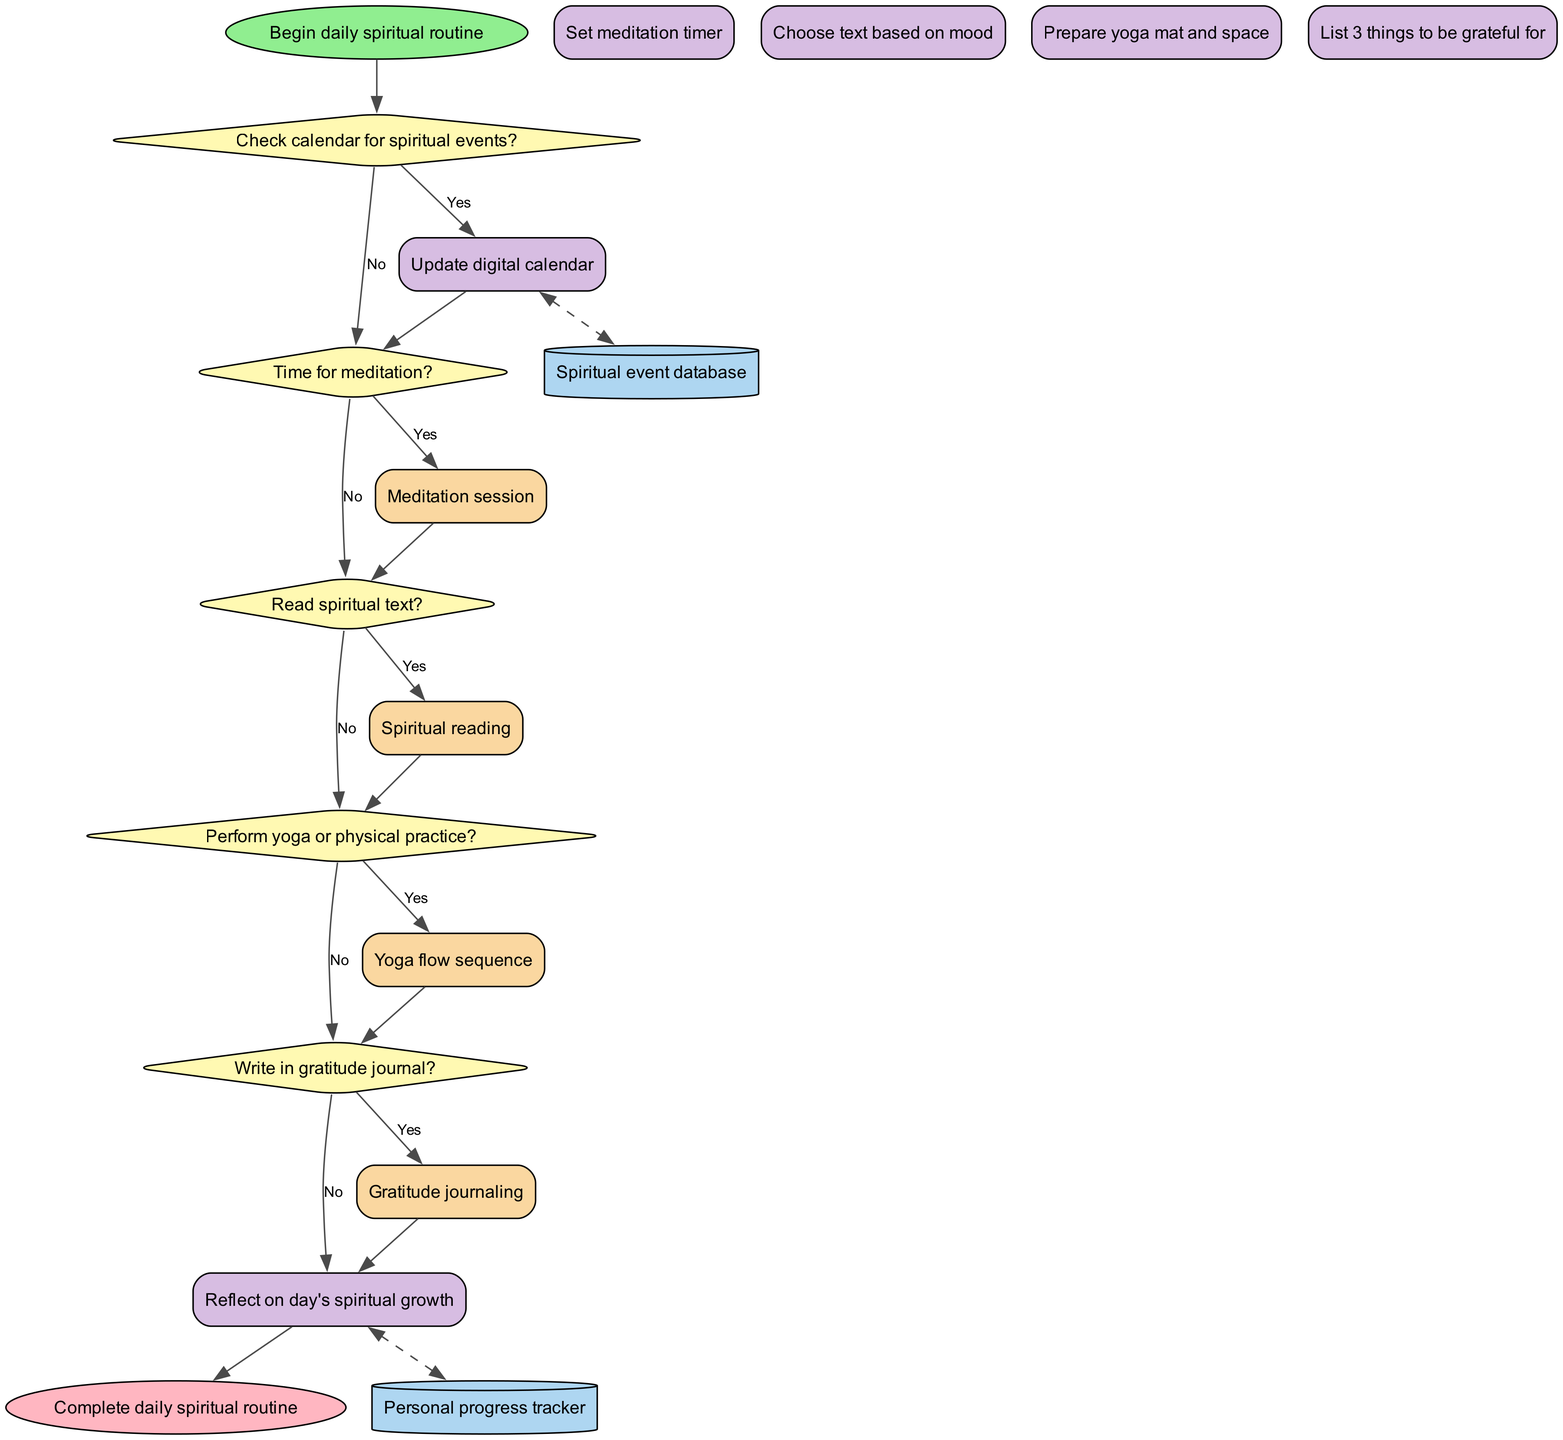What is the starting node of the flowchart? The starting node is labeled "Begin daily spiritual routine", which indicates where the flow starts.
Answer: Begin daily spiritual routine How many decision nodes are in the diagram? There are five decision nodes connected in the flowchart, each representing a question about the spiritual routine.
Answer: 5 What is the first action taken if the calendar has spiritual events? If the calendar has spiritual events, the first action taken is to "Update digital calendar", indicating the flow of activity that follows.
Answer: Update digital calendar What happens if there is no time for meditation? If there is no time for meditation, the flow proceeds to the next decision node regarding reading spiritual text, indicating that subsequent activities are alternatives based on time availability.
Answer: Proceed to next activity Which subprocess follows the action of "Prepare yoga mat and space"? After preparing the yoga mat and space, the subprocess that follows is the "Yoga flow sequence", indicating it is the next step in the spiritual routine.
Answer: Yoga flow sequence How many actions are linked to the decision node "Read spiritual text?"? There are two connections to the decision node "Read spiritual text?", leading to either performing the spiritual reading or moving on to the next decision about yoga.
Answer: 2 What data store is updated after writing in the gratitude journal? After writing in the gratitude journal, the data store "Personal progress tracker" is updated, which tracks the user's spiritual growth.
Answer: Personal progress tracker If meditation is performed, what action follows? If meditation is performed, the following action involves moving to the next decision concerning whether to read a spiritual text, maintaining the flow of the routine.
Answer: Proceed to next activity What color represents the end node in the flowchart? The end node is colored light pink, which visually distinguishes it as the endpoint of the spiritual routine flow.
Answer: Light pink 